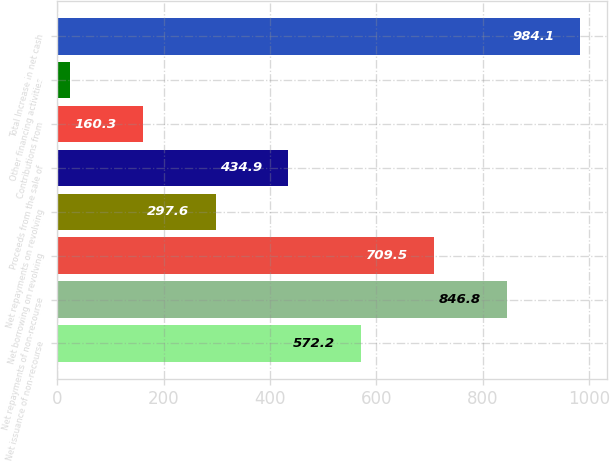<chart> <loc_0><loc_0><loc_500><loc_500><bar_chart><fcel>Net issuance of non-recourse<fcel>Net repayments of non-recourse<fcel>Net borrowing on revolving<fcel>Net repayments on revolving<fcel>Proceeds from the sale of<fcel>Contributions from<fcel>Other financing activities<fcel>Total Increase in net cash<nl><fcel>572.2<fcel>846.8<fcel>709.5<fcel>297.6<fcel>434.9<fcel>160.3<fcel>23<fcel>984.1<nl></chart> 